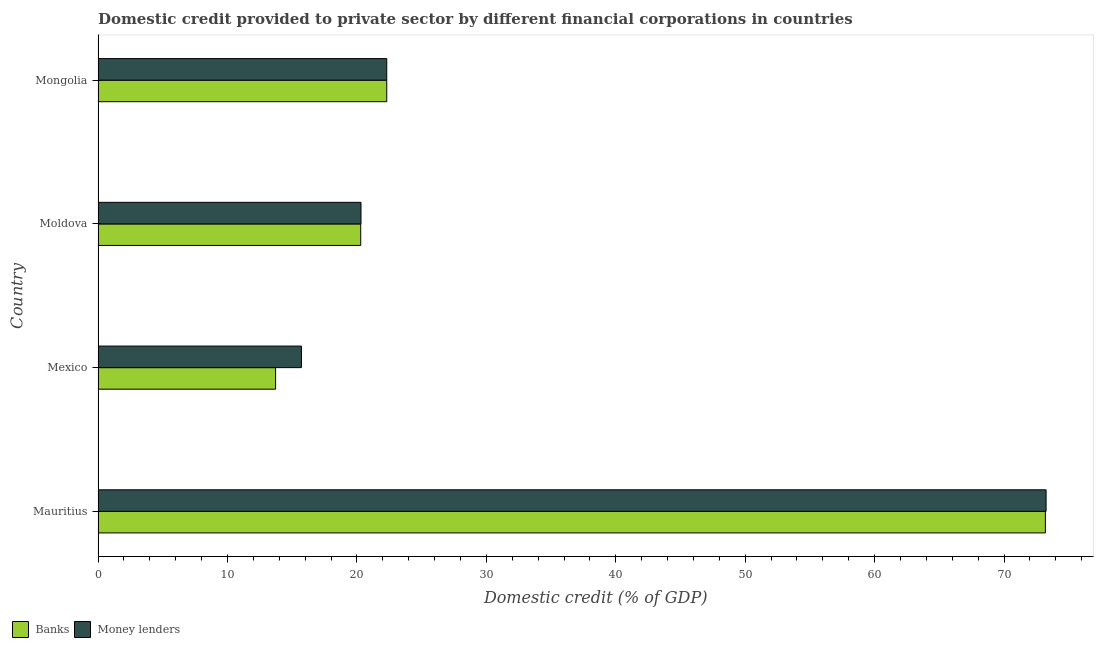Are the number of bars per tick equal to the number of legend labels?
Your response must be concise. Yes. Are the number of bars on each tick of the Y-axis equal?
Keep it short and to the point. Yes. What is the label of the 1st group of bars from the top?
Your answer should be compact. Mongolia. In how many cases, is the number of bars for a given country not equal to the number of legend labels?
Your answer should be very brief. 0. What is the domestic credit provided by banks in Mauritius?
Offer a very short reply. 73.19. Across all countries, what is the maximum domestic credit provided by money lenders?
Offer a very short reply. 73.25. Across all countries, what is the minimum domestic credit provided by banks?
Keep it short and to the point. 13.72. In which country was the domestic credit provided by banks maximum?
Make the answer very short. Mauritius. What is the total domestic credit provided by banks in the graph?
Your answer should be compact. 129.51. What is the difference between the domestic credit provided by money lenders in Moldova and that in Mongolia?
Provide a short and direct response. -1.99. What is the difference between the domestic credit provided by money lenders in Mongolia and the domestic credit provided by banks in Moldova?
Provide a short and direct response. 2.01. What is the average domestic credit provided by banks per country?
Your response must be concise. 32.38. What is the difference between the domestic credit provided by banks and domestic credit provided by money lenders in Mauritius?
Provide a short and direct response. -0.05. What is the ratio of the domestic credit provided by money lenders in Mauritius to that in Mexico?
Your response must be concise. 4.66. Is the difference between the domestic credit provided by banks in Mauritius and Mexico greater than the difference between the domestic credit provided by money lenders in Mauritius and Mexico?
Ensure brevity in your answer.  Yes. What is the difference between the highest and the second highest domestic credit provided by banks?
Provide a succinct answer. 50.89. What is the difference between the highest and the lowest domestic credit provided by banks?
Give a very brief answer. 59.48. In how many countries, is the domestic credit provided by banks greater than the average domestic credit provided by banks taken over all countries?
Provide a succinct answer. 1. What does the 2nd bar from the top in Mongolia represents?
Provide a succinct answer. Banks. What does the 2nd bar from the bottom in Mexico represents?
Your answer should be compact. Money lenders. What is the difference between two consecutive major ticks on the X-axis?
Your response must be concise. 10. Are the values on the major ticks of X-axis written in scientific E-notation?
Provide a succinct answer. No. Does the graph contain grids?
Make the answer very short. No. How many legend labels are there?
Offer a very short reply. 2. What is the title of the graph?
Make the answer very short. Domestic credit provided to private sector by different financial corporations in countries. Does "Automatic Teller Machines" appear as one of the legend labels in the graph?
Ensure brevity in your answer.  No. What is the label or title of the X-axis?
Your answer should be compact. Domestic credit (% of GDP). What is the Domestic credit (% of GDP) of Banks in Mauritius?
Keep it short and to the point. 73.19. What is the Domestic credit (% of GDP) in Money lenders in Mauritius?
Offer a terse response. 73.25. What is the Domestic credit (% of GDP) of Banks in Mexico?
Provide a short and direct response. 13.72. What is the Domestic credit (% of GDP) in Money lenders in Mexico?
Make the answer very short. 15.71. What is the Domestic credit (% of GDP) of Banks in Moldova?
Make the answer very short. 20.29. What is the Domestic credit (% of GDP) in Money lenders in Moldova?
Offer a terse response. 20.32. What is the Domestic credit (% of GDP) in Banks in Mongolia?
Provide a succinct answer. 22.31. What is the Domestic credit (% of GDP) in Money lenders in Mongolia?
Ensure brevity in your answer.  22.31. Across all countries, what is the maximum Domestic credit (% of GDP) of Banks?
Keep it short and to the point. 73.19. Across all countries, what is the maximum Domestic credit (% of GDP) of Money lenders?
Offer a very short reply. 73.25. Across all countries, what is the minimum Domestic credit (% of GDP) of Banks?
Provide a succinct answer. 13.72. Across all countries, what is the minimum Domestic credit (% of GDP) in Money lenders?
Provide a succinct answer. 15.71. What is the total Domestic credit (% of GDP) of Banks in the graph?
Give a very brief answer. 129.51. What is the total Domestic credit (% of GDP) in Money lenders in the graph?
Your answer should be very brief. 131.58. What is the difference between the Domestic credit (% of GDP) of Banks in Mauritius and that in Mexico?
Provide a succinct answer. 59.48. What is the difference between the Domestic credit (% of GDP) in Money lenders in Mauritius and that in Mexico?
Give a very brief answer. 57.53. What is the difference between the Domestic credit (% of GDP) in Banks in Mauritius and that in Moldova?
Offer a terse response. 52.9. What is the difference between the Domestic credit (% of GDP) in Money lenders in Mauritius and that in Moldova?
Your answer should be compact. 52.93. What is the difference between the Domestic credit (% of GDP) of Banks in Mauritius and that in Mongolia?
Offer a terse response. 50.89. What is the difference between the Domestic credit (% of GDP) in Money lenders in Mauritius and that in Mongolia?
Give a very brief answer. 50.94. What is the difference between the Domestic credit (% of GDP) of Banks in Mexico and that in Moldova?
Your response must be concise. -6.58. What is the difference between the Domestic credit (% of GDP) of Money lenders in Mexico and that in Moldova?
Your answer should be very brief. -4.6. What is the difference between the Domestic credit (% of GDP) in Banks in Mexico and that in Mongolia?
Provide a succinct answer. -8.59. What is the difference between the Domestic credit (% of GDP) in Money lenders in Mexico and that in Mongolia?
Your answer should be very brief. -6.59. What is the difference between the Domestic credit (% of GDP) in Banks in Moldova and that in Mongolia?
Your answer should be very brief. -2.01. What is the difference between the Domestic credit (% of GDP) in Money lenders in Moldova and that in Mongolia?
Offer a terse response. -1.99. What is the difference between the Domestic credit (% of GDP) in Banks in Mauritius and the Domestic credit (% of GDP) in Money lenders in Mexico?
Ensure brevity in your answer.  57.48. What is the difference between the Domestic credit (% of GDP) of Banks in Mauritius and the Domestic credit (% of GDP) of Money lenders in Moldova?
Keep it short and to the point. 52.88. What is the difference between the Domestic credit (% of GDP) in Banks in Mauritius and the Domestic credit (% of GDP) in Money lenders in Mongolia?
Give a very brief answer. 50.89. What is the difference between the Domestic credit (% of GDP) in Banks in Mexico and the Domestic credit (% of GDP) in Money lenders in Moldova?
Keep it short and to the point. -6.6. What is the difference between the Domestic credit (% of GDP) of Banks in Mexico and the Domestic credit (% of GDP) of Money lenders in Mongolia?
Provide a succinct answer. -8.59. What is the difference between the Domestic credit (% of GDP) of Banks in Moldova and the Domestic credit (% of GDP) of Money lenders in Mongolia?
Make the answer very short. -2.01. What is the average Domestic credit (% of GDP) in Banks per country?
Provide a succinct answer. 32.38. What is the average Domestic credit (% of GDP) of Money lenders per country?
Provide a short and direct response. 32.9. What is the difference between the Domestic credit (% of GDP) in Banks and Domestic credit (% of GDP) in Money lenders in Mauritius?
Provide a succinct answer. -0.05. What is the difference between the Domestic credit (% of GDP) of Banks and Domestic credit (% of GDP) of Money lenders in Mexico?
Ensure brevity in your answer.  -2. What is the difference between the Domestic credit (% of GDP) in Banks and Domestic credit (% of GDP) in Money lenders in Moldova?
Offer a terse response. -0.02. What is the ratio of the Domestic credit (% of GDP) of Banks in Mauritius to that in Mexico?
Your answer should be very brief. 5.34. What is the ratio of the Domestic credit (% of GDP) in Money lenders in Mauritius to that in Mexico?
Provide a succinct answer. 4.66. What is the ratio of the Domestic credit (% of GDP) in Banks in Mauritius to that in Moldova?
Ensure brevity in your answer.  3.61. What is the ratio of the Domestic credit (% of GDP) in Money lenders in Mauritius to that in Moldova?
Provide a short and direct response. 3.61. What is the ratio of the Domestic credit (% of GDP) in Banks in Mauritius to that in Mongolia?
Your answer should be compact. 3.28. What is the ratio of the Domestic credit (% of GDP) in Money lenders in Mauritius to that in Mongolia?
Your answer should be compact. 3.28. What is the ratio of the Domestic credit (% of GDP) of Banks in Mexico to that in Moldova?
Offer a terse response. 0.68. What is the ratio of the Domestic credit (% of GDP) of Money lenders in Mexico to that in Moldova?
Offer a terse response. 0.77. What is the ratio of the Domestic credit (% of GDP) in Banks in Mexico to that in Mongolia?
Provide a short and direct response. 0.61. What is the ratio of the Domestic credit (% of GDP) in Money lenders in Mexico to that in Mongolia?
Offer a very short reply. 0.7. What is the ratio of the Domestic credit (% of GDP) of Banks in Moldova to that in Mongolia?
Ensure brevity in your answer.  0.91. What is the ratio of the Domestic credit (% of GDP) of Money lenders in Moldova to that in Mongolia?
Your answer should be compact. 0.91. What is the difference between the highest and the second highest Domestic credit (% of GDP) in Banks?
Offer a terse response. 50.89. What is the difference between the highest and the second highest Domestic credit (% of GDP) in Money lenders?
Your response must be concise. 50.94. What is the difference between the highest and the lowest Domestic credit (% of GDP) of Banks?
Ensure brevity in your answer.  59.48. What is the difference between the highest and the lowest Domestic credit (% of GDP) of Money lenders?
Provide a succinct answer. 57.53. 